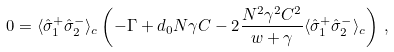<formula> <loc_0><loc_0><loc_500><loc_500>0 = \langle \hat { \sigma } _ { 1 } ^ { + } \hat { \sigma } _ { 2 } ^ { - } \rangle _ { c } \left ( - \Gamma + d _ { 0 } N \gamma C - 2 \frac { N ^ { 2 } \gamma ^ { 2 } C ^ { 2 } } { w + \gamma } \langle \hat { \sigma } _ { 1 } ^ { + } \hat { \sigma } _ { 2 } ^ { - } \rangle _ { c } \right ) \, ,</formula> 